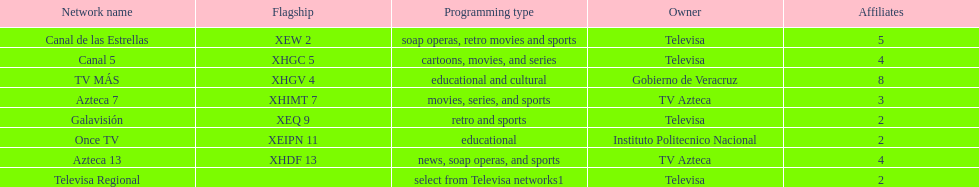How many networks contain more affiliates than canal de las estrellas? 1. Parse the full table. {'header': ['Network name', 'Flagship', 'Programming type', 'Owner', 'Affiliates'], 'rows': [['Canal de las Estrellas', 'XEW 2', 'soap operas, retro movies and sports', 'Televisa', '5'], ['Canal 5', 'XHGC 5', 'cartoons, movies, and series', 'Televisa', '4'], ['TV MÁS', 'XHGV 4', 'educational and cultural', 'Gobierno de Veracruz', '8'], ['Azteca 7', 'XHIMT 7', 'movies, series, and sports', 'TV Azteca', '3'], ['Galavisión', 'XEQ 9', 'retro and sports', 'Televisa', '2'], ['Once TV', 'XEIPN 11', 'educational', 'Instituto Politecnico Nacional', '2'], ['Azteca 13', 'XHDF 13', 'news, soap operas, and sports', 'TV Azteca', '4'], ['Televisa Regional', '', 'select from Televisa networks1', 'Televisa', '2']]} 